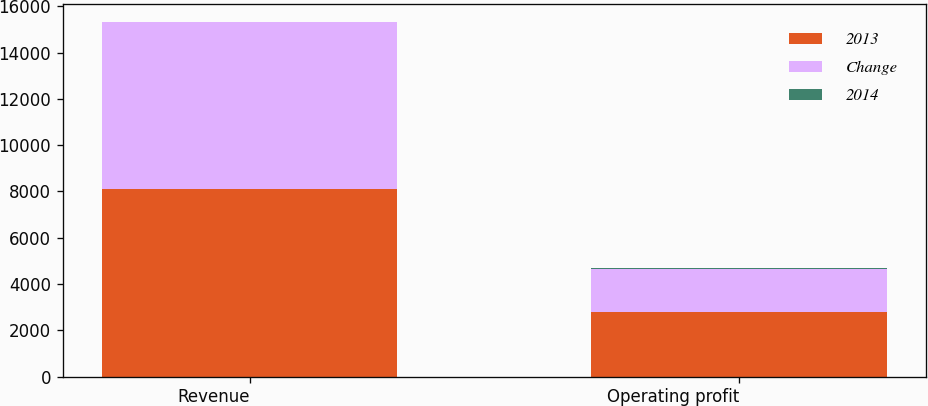<chart> <loc_0><loc_0><loc_500><loc_500><stacked_bar_chart><ecel><fcel>Revenue<fcel>Operating profit<nl><fcel>2013<fcel>8104<fcel>2786<nl><fcel>Change<fcel>7194<fcel>1859<nl><fcel>2014<fcel>13<fcel>50<nl></chart> 